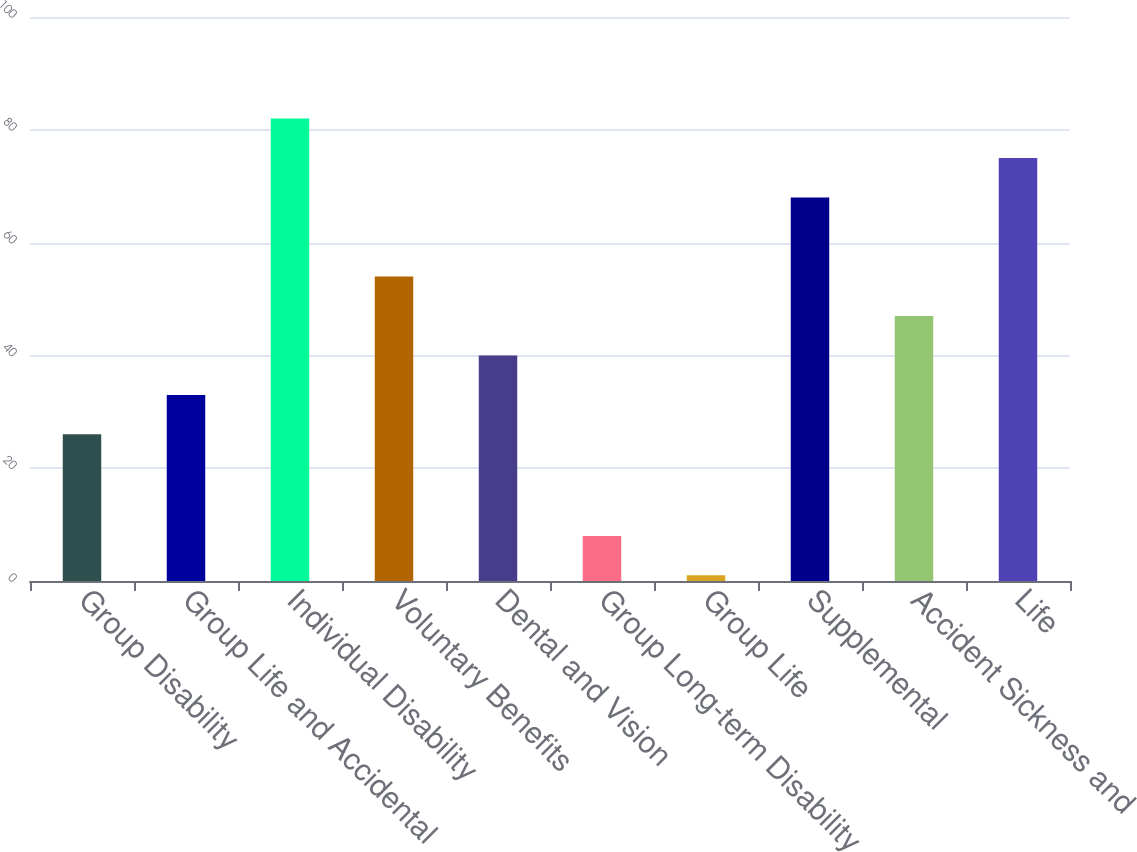Convert chart to OTSL. <chart><loc_0><loc_0><loc_500><loc_500><bar_chart><fcel>Group Disability<fcel>Group Life and Accidental<fcel>Individual Disability<fcel>Voluntary Benefits<fcel>Dental and Vision<fcel>Group Long-term Disability<fcel>Group Life<fcel>Supplemental<fcel>Accident Sickness and<fcel>Life<nl><fcel>26<fcel>33<fcel>82<fcel>54<fcel>40<fcel>8<fcel>1<fcel>68<fcel>47<fcel>75<nl></chart> 